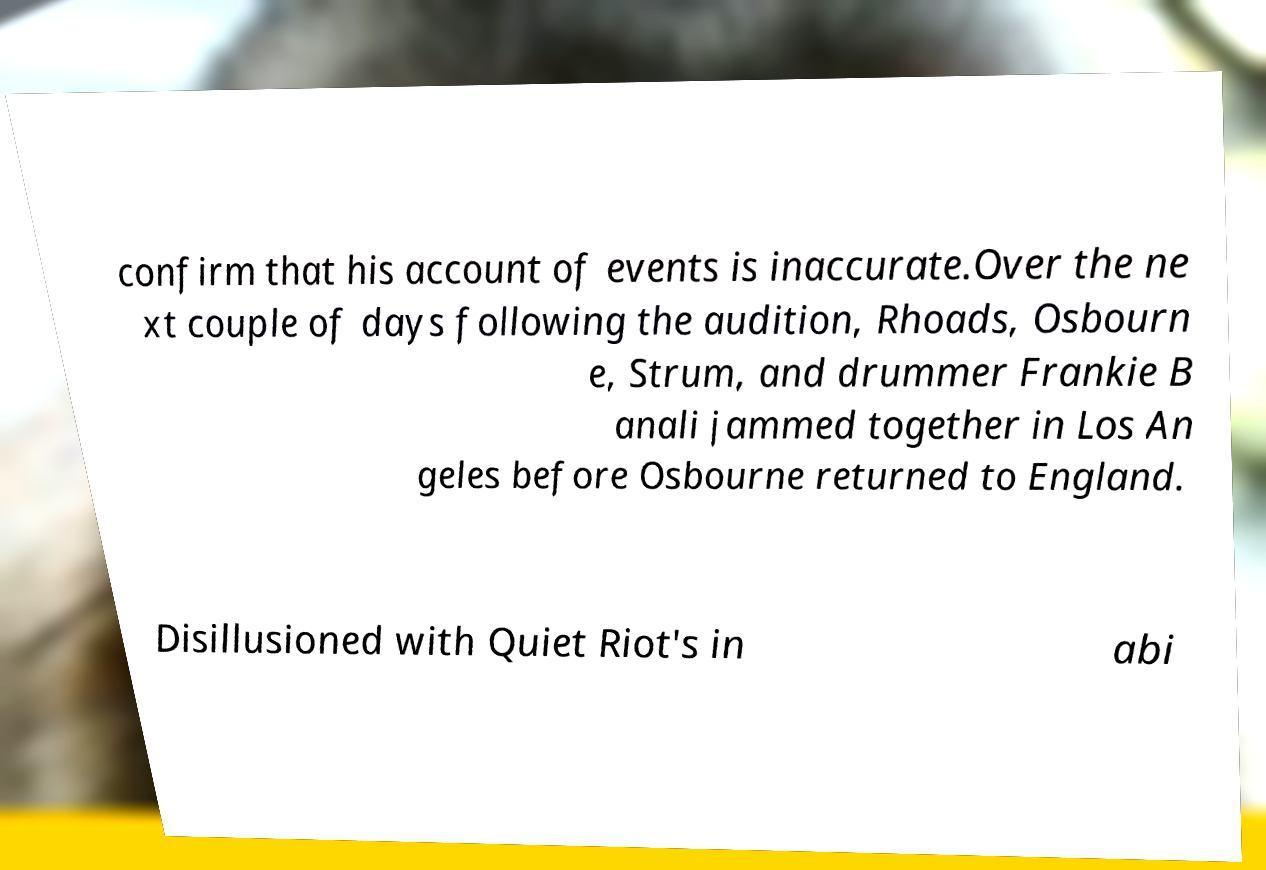Please read and relay the text visible in this image. What does it say? confirm that his account of events is inaccurate.Over the ne xt couple of days following the audition, Rhoads, Osbourn e, Strum, and drummer Frankie B anali jammed together in Los An geles before Osbourne returned to England. Disillusioned with Quiet Riot's in abi 